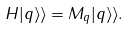<formula> <loc_0><loc_0><loc_500><loc_500>H | q \rangle \rangle = M _ { q } | q \rangle \rangle .</formula> 